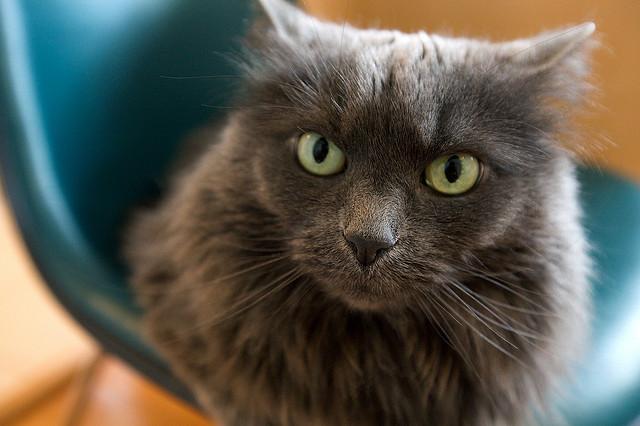What color is the cat?
Concise answer only. Gray. What is the cat sitting on?
Be succinct. Chair. What's the cat doing?
Give a very brief answer. Staring. What color is the cat's eyes?
Concise answer only. Green. How many cats are there?
Be succinct. 1. What is the cat laying on?
Short answer required. Chair. What color is this furry animal?
Short answer required. Gray. 